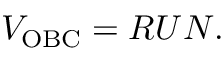<formula> <loc_0><loc_0><loc_500><loc_500>\begin{array} { r } { V _ { O B C } = R U N . } \end{array}</formula> 